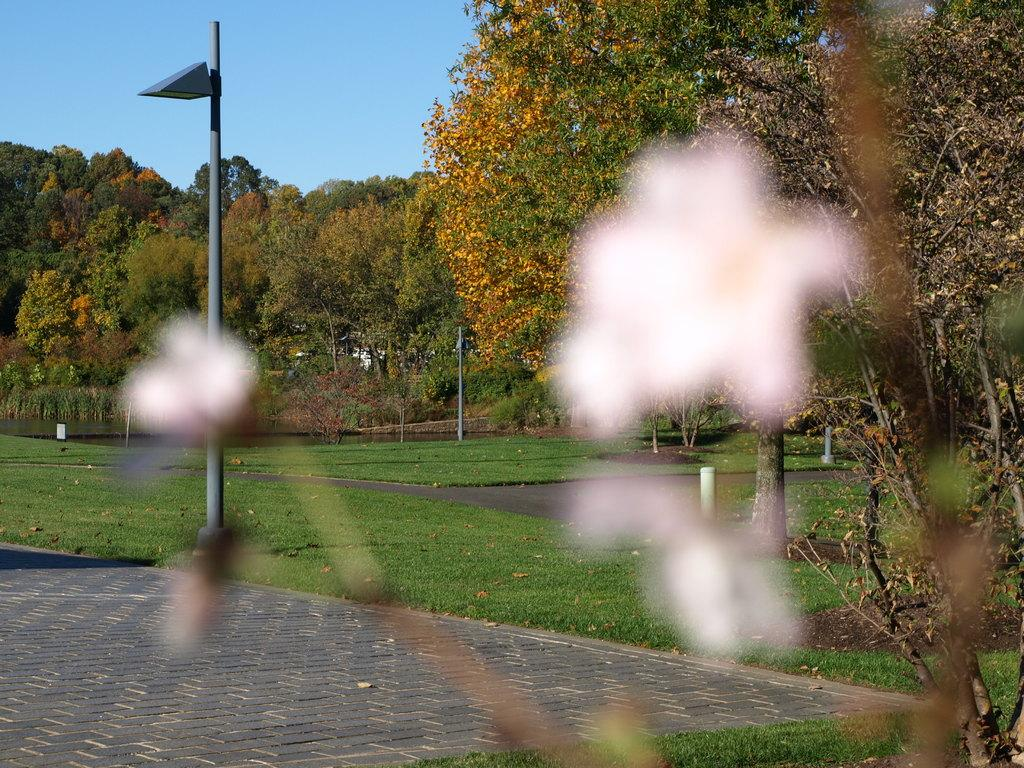What structures are present in the image? There are poles in the image. What type of natural environment is visible in the image? There is grass visible in the image. What type of vegetation is present in the image? There are trees in the image. What type of cent can be seen riding on the poles in the image? There is no cent present in the image, and therefore no such activity can be observed. What type of flag is attached to the poles in the image? There is no flag attached to the poles in the image. What type of songs can be heard being sung by the trees in the image? Trees do not have the ability to sing songs, so there are no songs being sung by the trees in the image. 